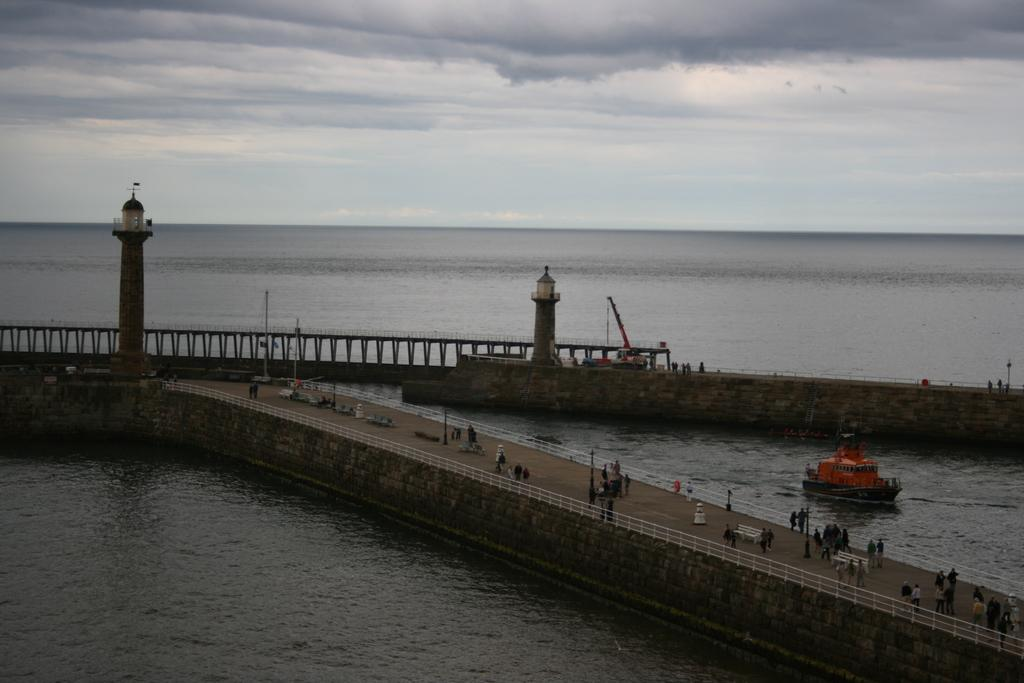What is present on both sides of the image? There is water on both the right and left sides of the image. What structure can be seen in the center of the image? There is a dock in the center of the image. What architectural features are present on both sides of the image? There are two pillars on both the right and left sides of the image. What type of mint is growing on the dock in the image? There is no mint present in the image; it features water, a dock, and pillars. How many heads are visible in the image? There are no heads visible in the image; it features water, a dock, and pillars. 